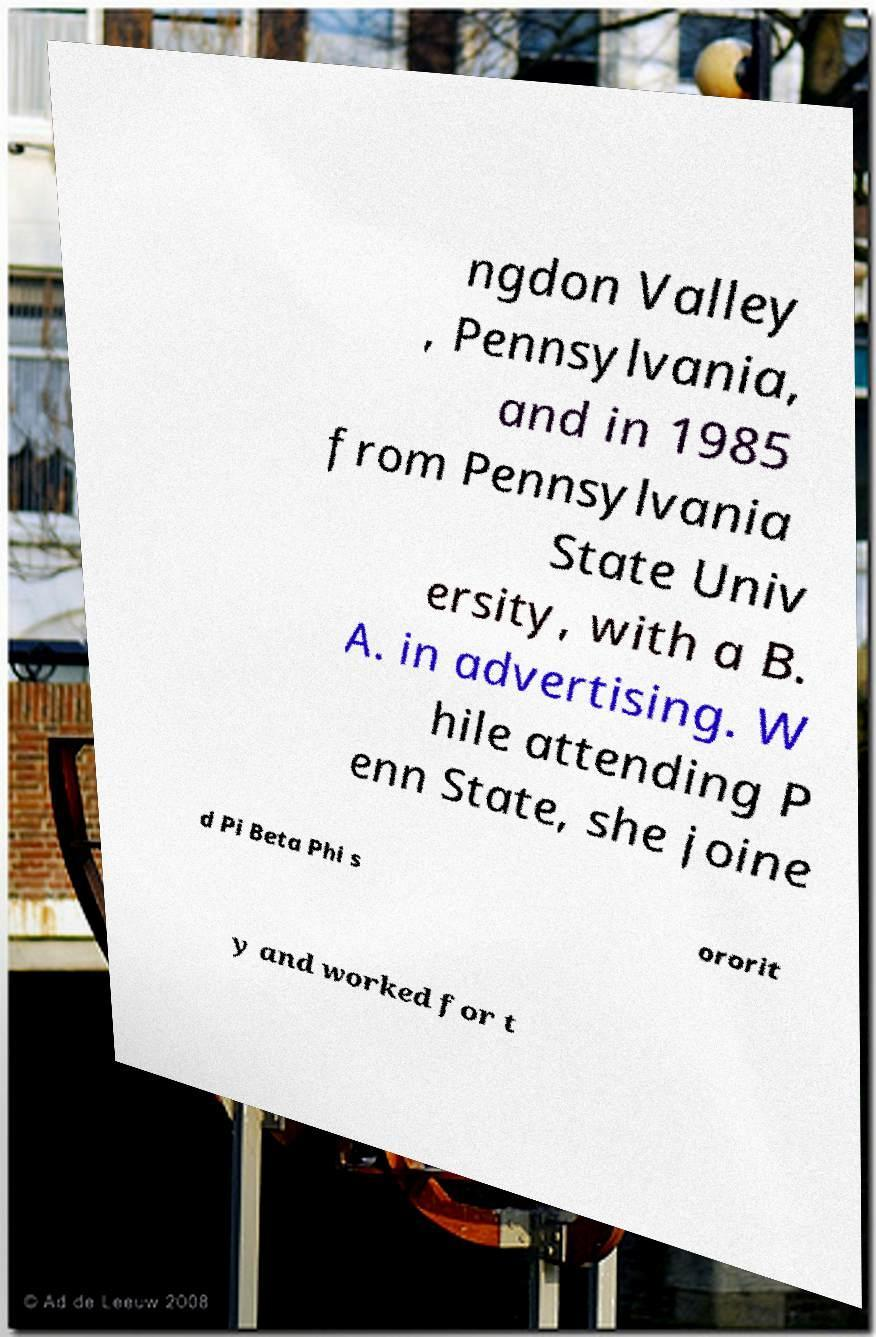I need the written content from this picture converted into text. Can you do that? ngdon Valley , Pennsylvania, and in 1985 from Pennsylvania State Univ ersity, with a B. A. in advertising. W hile attending P enn State, she joine d Pi Beta Phi s ororit y and worked for t 